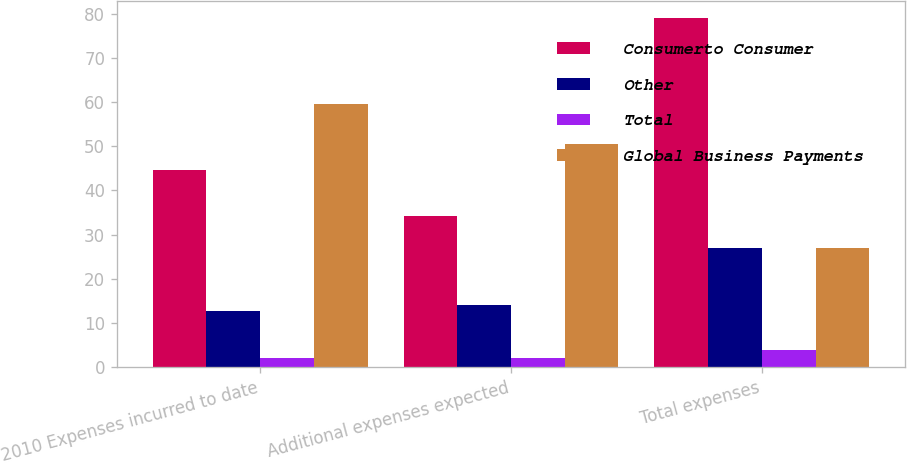<chart> <loc_0><loc_0><loc_500><loc_500><stacked_bar_chart><ecel><fcel>2010 Expenses incurred to date<fcel>Additional expenses expected<fcel>Total expenses<nl><fcel>Consumerto Consumer<fcel>44.7<fcel>34.3<fcel>79<nl><fcel>Other<fcel>12.8<fcel>14.2<fcel>27<nl><fcel>Total<fcel>2<fcel>2<fcel>4<nl><fcel>Global Business Payments<fcel>59.5<fcel>50.5<fcel>27<nl></chart> 